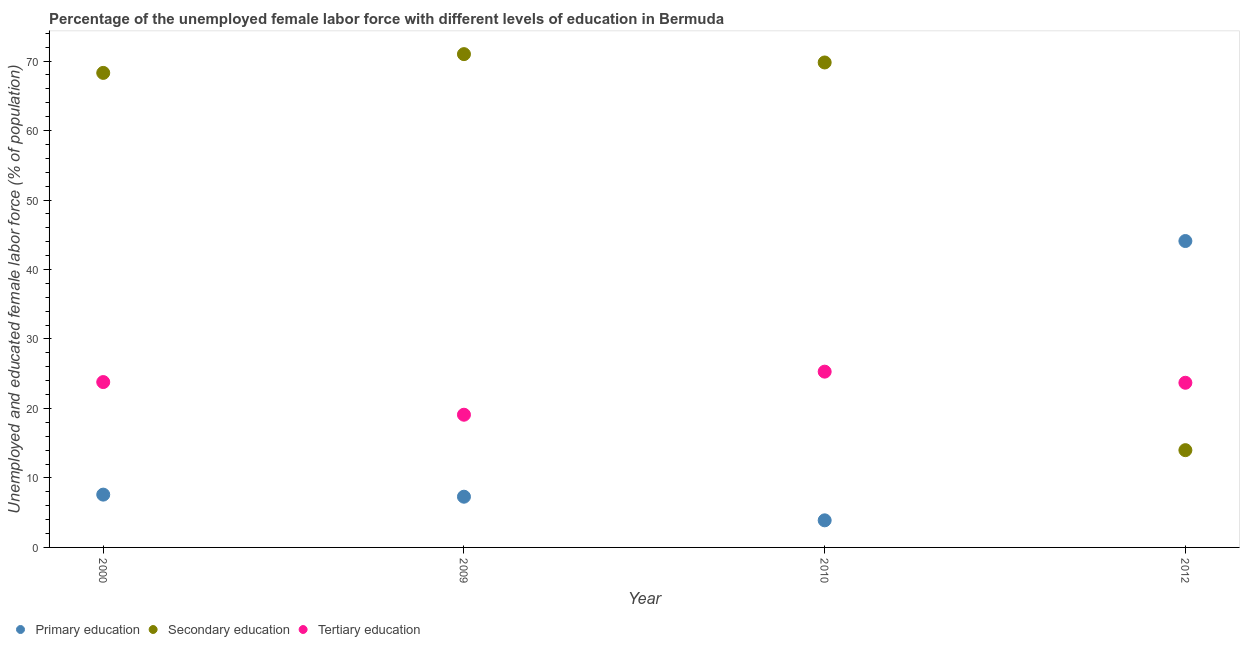What is the percentage of female labor force who received secondary education in 2010?
Your answer should be compact. 69.8. Across all years, what is the minimum percentage of female labor force who received secondary education?
Your answer should be very brief. 14. What is the total percentage of female labor force who received tertiary education in the graph?
Make the answer very short. 91.9. What is the difference between the percentage of female labor force who received tertiary education in 2000 and that in 2010?
Provide a succinct answer. -1.5. What is the difference between the percentage of female labor force who received secondary education in 2012 and the percentage of female labor force who received primary education in 2009?
Keep it short and to the point. 6.7. What is the average percentage of female labor force who received secondary education per year?
Provide a short and direct response. 55.78. In the year 2000, what is the difference between the percentage of female labor force who received primary education and percentage of female labor force who received secondary education?
Keep it short and to the point. -60.7. In how many years, is the percentage of female labor force who received secondary education greater than 64 %?
Your response must be concise. 3. What is the ratio of the percentage of female labor force who received secondary education in 2000 to that in 2009?
Your answer should be compact. 0.96. Is the percentage of female labor force who received tertiary education in 2000 less than that in 2010?
Keep it short and to the point. Yes. Is the difference between the percentage of female labor force who received tertiary education in 2000 and 2009 greater than the difference between the percentage of female labor force who received secondary education in 2000 and 2009?
Your response must be concise. Yes. What is the difference between the highest and the second highest percentage of female labor force who received secondary education?
Make the answer very short. 1.2. What is the difference between the highest and the lowest percentage of female labor force who received tertiary education?
Your answer should be compact. 6.2. Is the percentage of female labor force who received primary education strictly less than the percentage of female labor force who received tertiary education over the years?
Your response must be concise. No. Where does the legend appear in the graph?
Your response must be concise. Bottom left. How many legend labels are there?
Provide a short and direct response. 3. What is the title of the graph?
Keep it short and to the point. Percentage of the unemployed female labor force with different levels of education in Bermuda. Does "Interest" appear as one of the legend labels in the graph?
Make the answer very short. No. What is the label or title of the X-axis?
Give a very brief answer. Year. What is the label or title of the Y-axis?
Your answer should be compact. Unemployed and educated female labor force (% of population). What is the Unemployed and educated female labor force (% of population) of Primary education in 2000?
Provide a short and direct response. 7.6. What is the Unemployed and educated female labor force (% of population) in Secondary education in 2000?
Provide a succinct answer. 68.3. What is the Unemployed and educated female labor force (% of population) in Tertiary education in 2000?
Provide a short and direct response. 23.8. What is the Unemployed and educated female labor force (% of population) of Primary education in 2009?
Your response must be concise. 7.3. What is the Unemployed and educated female labor force (% of population) in Secondary education in 2009?
Provide a short and direct response. 71. What is the Unemployed and educated female labor force (% of population) of Tertiary education in 2009?
Ensure brevity in your answer.  19.1. What is the Unemployed and educated female labor force (% of population) in Primary education in 2010?
Make the answer very short. 3.9. What is the Unemployed and educated female labor force (% of population) in Secondary education in 2010?
Offer a very short reply. 69.8. What is the Unemployed and educated female labor force (% of population) of Tertiary education in 2010?
Make the answer very short. 25.3. What is the Unemployed and educated female labor force (% of population) of Primary education in 2012?
Keep it short and to the point. 44.1. What is the Unemployed and educated female labor force (% of population) of Secondary education in 2012?
Make the answer very short. 14. What is the Unemployed and educated female labor force (% of population) of Tertiary education in 2012?
Provide a short and direct response. 23.7. Across all years, what is the maximum Unemployed and educated female labor force (% of population) of Primary education?
Make the answer very short. 44.1. Across all years, what is the maximum Unemployed and educated female labor force (% of population) in Tertiary education?
Offer a very short reply. 25.3. Across all years, what is the minimum Unemployed and educated female labor force (% of population) in Primary education?
Ensure brevity in your answer.  3.9. Across all years, what is the minimum Unemployed and educated female labor force (% of population) of Tertiary education?
Make the answer very short. 19.1. What is the total Unemployed and educated female labor force (% of population) of Primary education in the graph?
Your answer should be very brief. 62.9. What is the total Unemployed and educated female labor force (% of population) in Secondary education in the graph?
Ensure brevity in your answer.  223.1. What is the total Unemployed and educated female labor force (% of population) of Tertiary education in the graph?
Provide a short and direct response. 91.9. What is the difference between the Unemployed and educated female labor force (% of population) of Primary education in 2000 and that in 2009?
Provide a succinct answer. 0.3. What is the difference between the Unemployed and educated female labor force (% of population) of Secondary education in 2000 and that in 2009?
Provide a succinct answer. -2.7. What is the difference between the Unemployed and educated female labor force (% of population) of Tertiary education in 2000 and that in 2009?
Make the answer very short. 4.7. What is the difference between the Unemployed and educated female labor force (% of population) of Primary education in 2000 and that in 2012?
Offer a very short reply. -36.5. What is the difference between the Unemployed and educated female labor force (% of population) of Secondary education in 2000 and that in 2012?
Your answer should be compact. 54.3. What is the difference between the Unemployed and educated female labor force (% of population) of Tertiary education in 2000 and that in 2012?
Your answer should be compact. 0.1. What is the difference between the Unemployed and educated female labor force (% of population) in Secondary education in 2009 and that in 2010?
Your response must be concise. 1.2. What is the difference between the Unemployed and educated female labor force (% of population) of Tertiary education in 2009 and that in 2010?
Ensure brevity in your answer.  -6.2. What is the difference between the Unemployed and educated female labor force (% of population) of Primary education in 2009 and that in 2012?
Make the answer very short. -36.8. What is the difference between the Unemployed and educated female labor force (% of population) in Secondary education in 2009 and that in 2012?
Provide a succinct answer. 57. What is the difference between the Unemployed and educated female labor force (% of population) of Tertiary education in 2009 and that in 2012?
Provide a short and direct response. -4.6. What is the difference between the Unemployed and educated female labor force (% of population) of Primary education in 2010 and that in 2012?
Provide a short and direct response. -40.2. What is the difference between the Unemployed and educated female labor force (% of population) of Secondary education in 2010 and that in 2012?
Ensure brevity in your answer.  55.8. What is the difference between the Unemployed and educated female labor force (% of population) of Primary education in 2000 and the Unemployed and educated female labor force (% of population) of Secondary education in 2009?
Keep it short and to the point. -63.4. What is the difference between the Unemployed and educated female labor force (% of population) of Primary education in 2000 and the Unemployed and educated female labor force (% of population) of Tertiary education in 2009?
Make the answer very short. -11.5. What is the difference between the Unemployed and educated female labor force (% of population) of Secondary education in 2000 and the Unemployed and educated female labor force (% of population) of Tertiary education in 2009?
Offer a terse response. 49.2. What is the difference between the Unemployed and educated female labor force (% of population) in Primary education in 2000 and the Unemployed and educated female labor force (% of population) in Secondary education in 2010?
Your answer should be compact. -62.2. What is the difference between the Unemployed and educated female labor force (% of population) of Primary education in 2000 and the Unemployed and educated female labor force (% of population) of Tertiary education in 2010?
Ensure brevity in your answer.  -17.7. What is the difference between the Unemployed and educated female labor force (% of population) in Secondary education in 2000 and the Unemployed and educated female labor force (% of population) in Tertiary education in 2010?
Your response must be concise. 43. What is the difference between the Unemployed and educated female labor force (% of population) of Primary education in 2000 and the Unemployed and educated female labor force (% of population) of Secondary education in 2012?
Give a very brief answer. -6.4. What is the difference between the Unemployed and educated female labor force (% of population) in Primary education in 2000 and the Unemployed and educated female labor force (% of population) in Tertiary education in 2012?
Provide a short and direct response. -16.1. What is the difference between the Unemployed and educated female labor force (% of population) in Secondary education in 2000 and the Unemployed and educated female labor force (% of population) in Tertiary education in 2012?
Your answer should be very brief. 44.6. What is the difference between the Unemployed and educated female labor force (% of population) in Primary education in 2009 and the Unemployed and educated female labor force (% of population) in Secondary education in 2010?
Your answer should be very brief. -62.5. What is the difference between the Unemployed and educated female labor force (% of population) of Secondary education in 2009 and the Unemployed and educated female labor force (% of population) of Tertiary education in 2010?
Your answer should be very brief. 45.7. What is the difference between the Unemployed and educated female labor force (% of population) of Primary education in 2009 and the Unemployed and educated female labor force (% of population) of Tertiary education in 2012?
Keep it short and to the point. -16.4. What is the difference between the Unemployed and educated female labor force (% of population) of Secondary education in 2009 and the Unemployed and educated female labor force (% of population) of Tertiary education in 2012?
Your answer should be compact. 47.3. What is the difference between the Unemployed and educated female labor force (% of population) of Primary education in 2010 and the Unemployed and educated female labor force (% of population) of Secondary education in 2012?
Make the answer very short. -10.1. What is the difference between the Unemployed and educated female labor force (% of population) of Primary education in 2010 and the Unemployed and educated female labor force (% of population) of Tertiary education in 2012?
Keep it short and to the point. -19.8. What is the difference between the Unemployed and educated female labor force (% of population) in Secondary education in 2010 and the Unemployed and educated female labor force (% of population) in Tertiary education in 2012?
Ensure brevity in your answer.  46.1. What is the average Unemployed and educated female labor force (% of population) in Primary education per year?
Provide a short and direct response. 15.72. What is the average Unemployed and educated female labor force (% of population) in Secondary education per year?
Your answer should be very brief. 55.77. What is the average Unemployed and educated female labor force (% of population) in Tertiary education per year?
Keep it short and to the point. 22.98. In the year 2000, what is the difference between the Unemployed and educated female labor force (% of population) of Primary education and Unemployed and educated female labor force (% of population) of Secondary education?
Give a very brief answer. -60.7. In the year 2000, what is the difference between the Unemployed and educated female labor force (% of population) in Primary education and Unemployed and educated female labor force (% of population) in Tertiary education?
Offer a terse response. -16.2. In the year 2000, what is the difference between the Unemployed and educated female labor force (% of population) in Secondary education and Unemployed and educated female labor force (% of population) in Tertiary education?
Offer a very short reply. 44.5. In the year 2009, what is the difference between the Unemployed and educated female labor force (% of population) of Primary education and Unemployed and educated female labor force (% of population) of Secondary education?
Keep it short and to the point. -63.7. In the year 2009, what is the difference between the Unemployed and educated female labor force (% of population) of Secondary education and Unemployed and educated female labor force (% of population) of Tertiary education?
Your answer should be compact. 51.9. In the year 2010, what is the difference between the Unemployed and educated female labor force (% of population) in Primary education and Unemployed and educated female labor force (% of population) in Secondary education?
Ensure brevity in your answer.  -65.9. In the year 2010, what is the difference between the Unemployed and educated female labor force (% of population) of Primary education and Unemployed and educated female labor force (% of population) of Tertiary education?
Offer a very short reply. -21.4. In the year 2010, what is the difference between the Unemployed and educated female labor force (% of population) of Secondary education and Unemployed and educated female labor force (% of population) of Tertiary education?
Make the answer very short. 44.5. In the year 2012, what is the difference between the Unemployed and educated female labor force (% of population) in Primary education and Unemployed and educated female labor force (% of population) in Secondary education?
Give a very brief answer. 30.1. In the year 2012, what is the difference between the Unemployed and educated female labor force (% of population) in Primary education and Unemployed and educated female labor force (% of population) in Tertiary education?
Offer a terse response. 20.4. In the year 2012, what is the difference between the Unemployed and educated female labor force (% of population) of Secondary education and Unemployed and educated female labor force (% of population) of Tertiary education?
Your answer should be compact. -9.7. What is the ratio of the Unemployed and educated female labor force (% of population) in Primary education in 2000 to that in 2009?
Offer a terse response. 1.04. What is the ratio of the Unemployed and educated female labor force (% of population) of Secondary education in 2000 to that in 2009?
Provide a succinct answer. 0.96. What is the ratio of the Unemployed and educated female labor force (% of population) of Tertiary education in 2000 to that in 2009?
Make the answer very short. 1.25. What is the ratio of the Unemployed and educated female labor force (% of population) of Primary education in 2000 to that in 2010?
Offer a terse response. 1.95. What is the ratio of the Unemployed and educated female labor force (% of population) in Secondary education in 2000 to that in 2010?
Provide a short and direct response. 0.98. What is the ratio of the Unemployed and educated female labor force (% of population) of Tertiary education in 2000 to that in 2010?
Your response must be concise. 0.94. What is the ratio of the Unemployed and educated female labor force (% of population) in Primary education in 2000 to that in 2012?
Provide a succinct answer. 0.17. What is the ratio of the Unemployed and educated female labor force (% of population) in Secondary education in 2000 to that in 2012?
Provide a short and direct response. 4.88. What is the ratio of the Unemployed and educated female labor force (% of population) of Tertiary education in 2000 to that in 2012?
Give a very brief answer. 1. What is the ratio of the Unemployed and educated female labor force (% of population) in Primary education in 2009 to that in 2010?
Make the answer very short. 1.87. What is the ratio of the Unemployed and educated female labor force (% of population) of Secondary education in 2009 to that in 2010?
Provide a short and direct response. 1.02. What is the ratio of the Unemployed and educated female labor force (% of population) of Tertiary education in 2009 to that in 2010?
Ensure brevity in your answer.  0.75. What is the ratio of the Unemployed and educated female labor force (% of population) of Primary education in 2009 to that in 2012?
Offer a very short reply. 0.17. What is the ratio of the Unemployed and educated female labor force (% of population) in Secondary education in 2009 to that in 2012?
Make the answer very short. 5.07. What is the ratio of the Unemployed and educated female labor force (% of population) of Tertiary education in 2009 to that in 2012?
Offer a terse response. 0.81. What is the ratio of the Unemployed and educated female labor force (% of population) in Primary education in 2010 to that in 2012?
Your response must be concise. 0.09. What is the ratio of the Unemployed and educated female labor force (% of population) of Secondary education in 2010 to that in 2012?
Keep it short and to the point. 4.99. What is the ratio of the Unemployed and educated female labor force (% of population) of Tertiary education in 2010 to that in 2012?
Keep it short and to the point. 1.07. What is the difference between the highest and the second highest Unemployed and educated female labor force (% of population) in Primary education?
Offer a very short reply. 36.5. What is the difference between the highest and the second highest Unemployed and educated female labor force (% of population) of Tertiary education?
Offer a terse response. 1.5. What is the difference between the highest and the lowest Unemployed and educated female labor force (% of population) of Primary education?
Your answer should be very brief. 40.2. What is the difference between the highest and the lowest Unemployed and educated female labor force (% of population) in Tertiary education?
Make the answer very short. 6.2. 